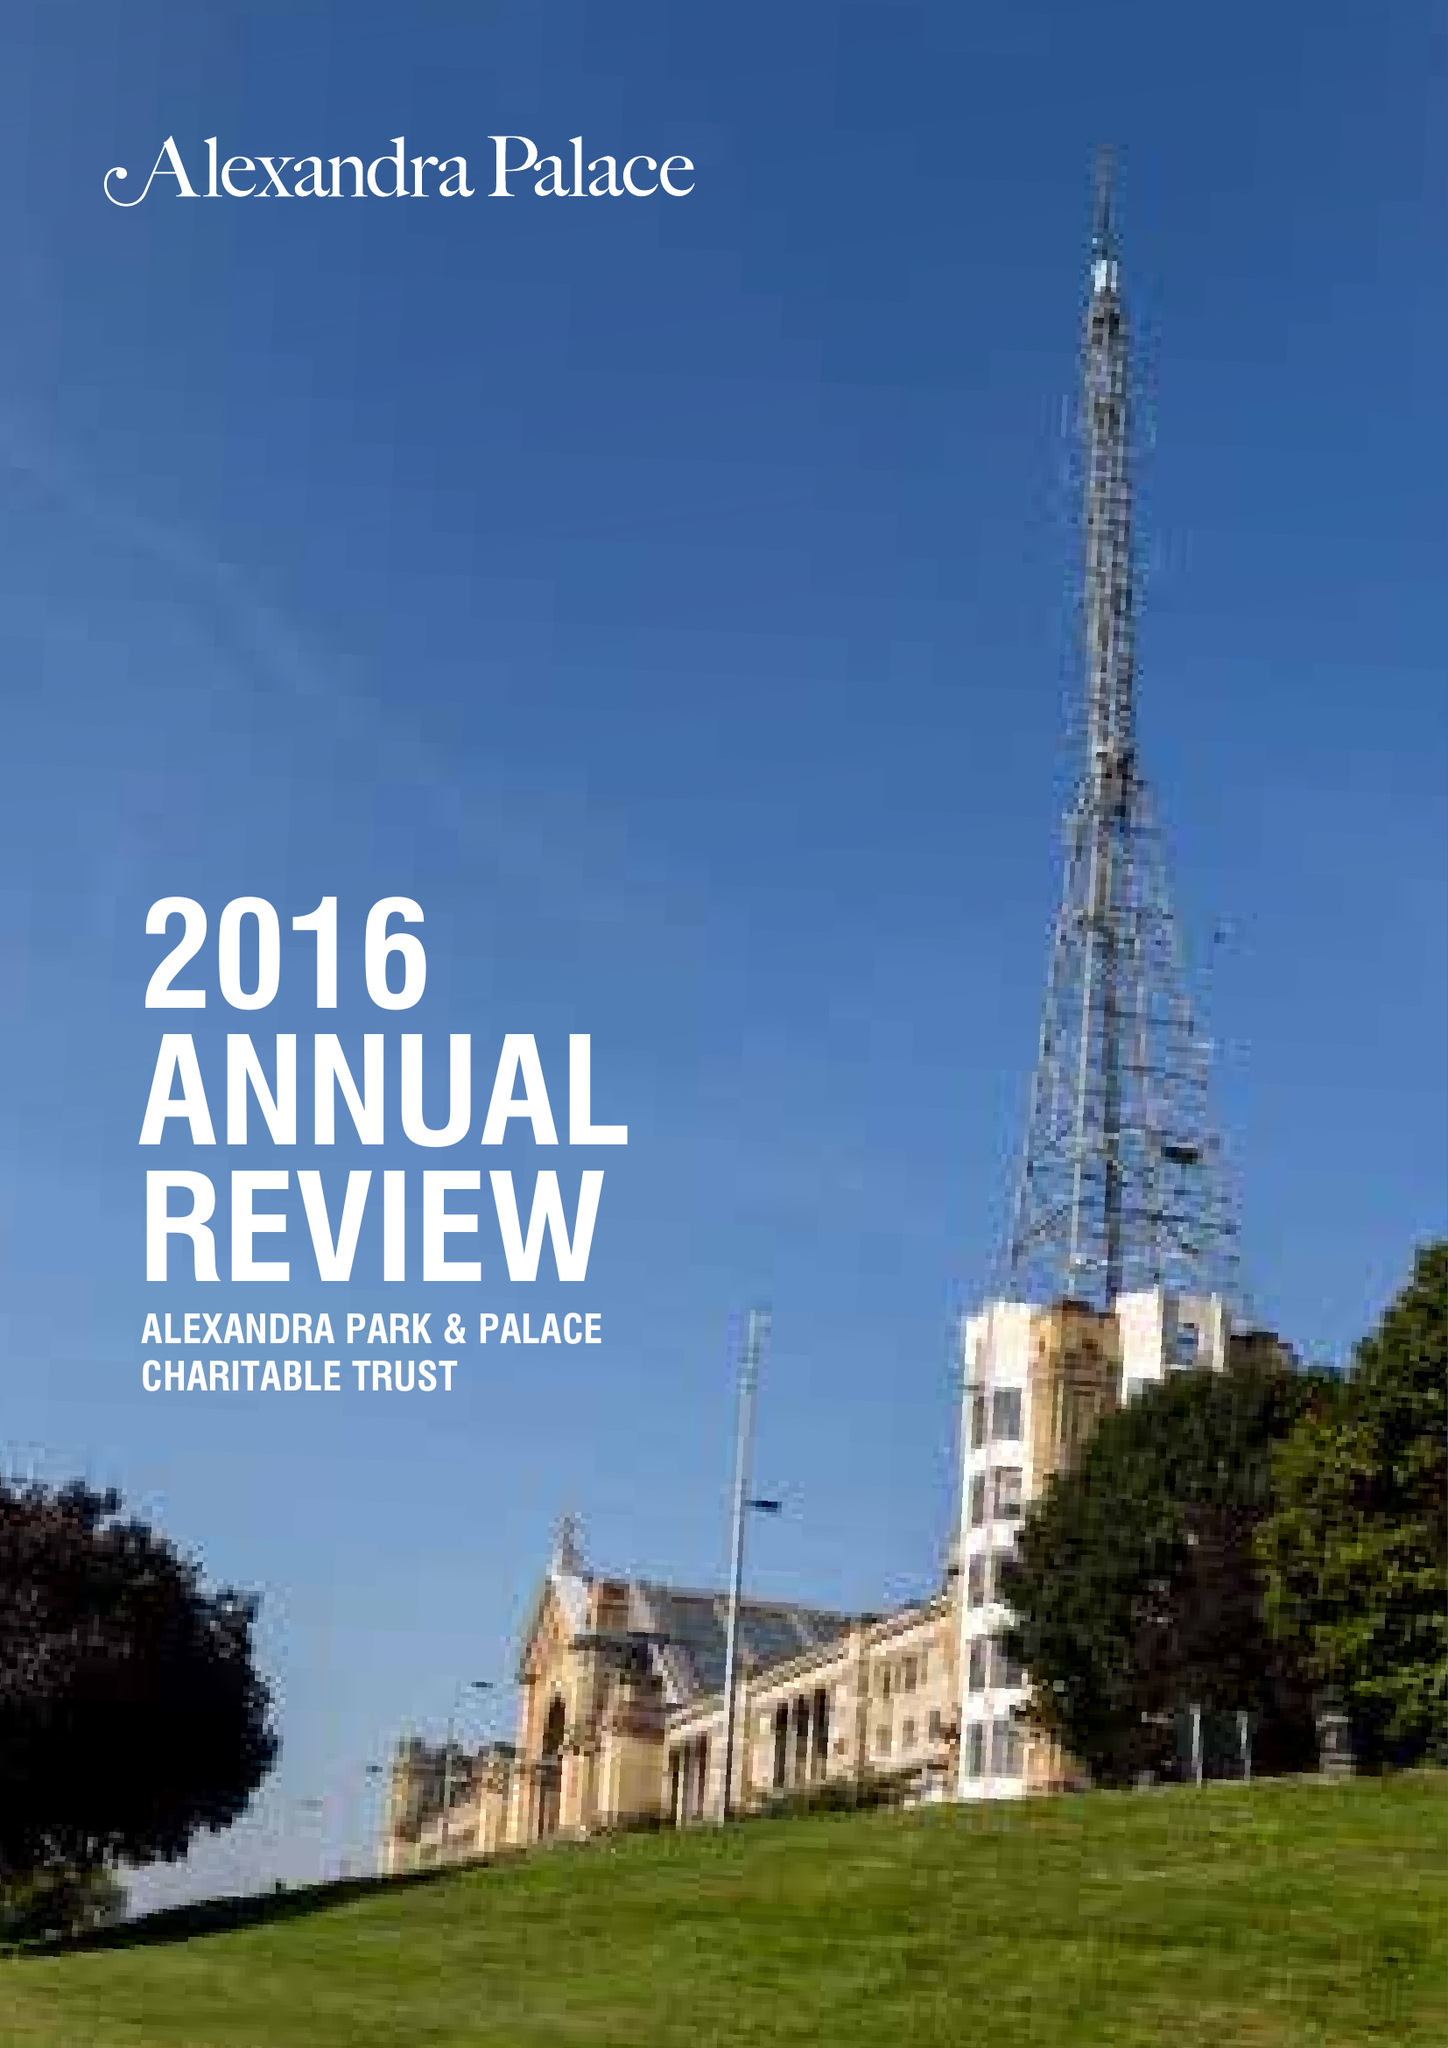What is the value for the address__post_town?
Answer the question using a single word or phrase. LONDON 